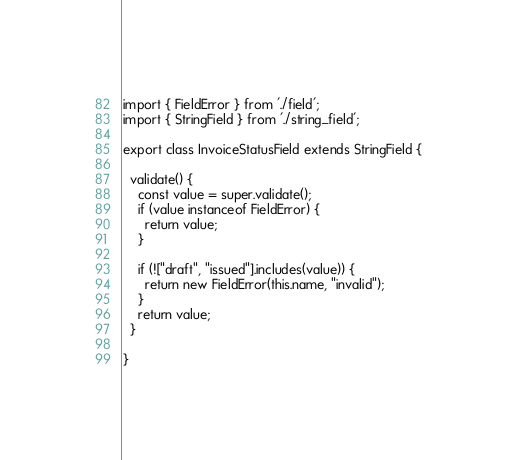<code> <loc_0><loc_0><loc_500><loc_500><_TypeScript_>import { FieldError } from './field';
import { StringField } from './string_field';

export class InvoiceStatusField extends StringField {

  validate() {
    const value = super.validate();
    if (value instanceof FieldError) {
      return value;
    }

    if (!["draft", "issued"].includes(value)) {
      return new FieldError(this.name, "invalid");
    }
    return value;
  }

}</code> 